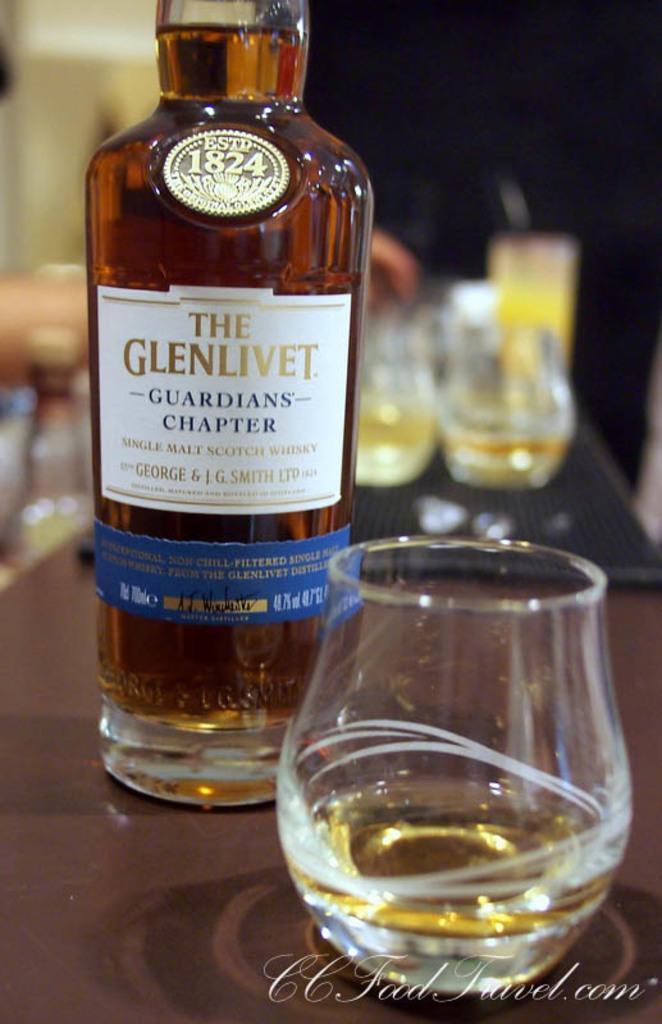<image>
Create a compact narrative representing the image presented. A bottle of The Glenlivet next to a glass on a table. 